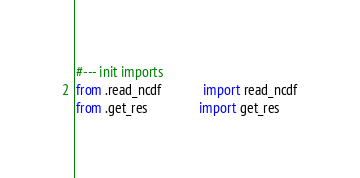<code> <loc_0><loc_0><loc_500><loc_500><_Python_>#--- init imports
from .read_ncdf 	        import read_ncdf
from .get_res               import get_res

</code> 